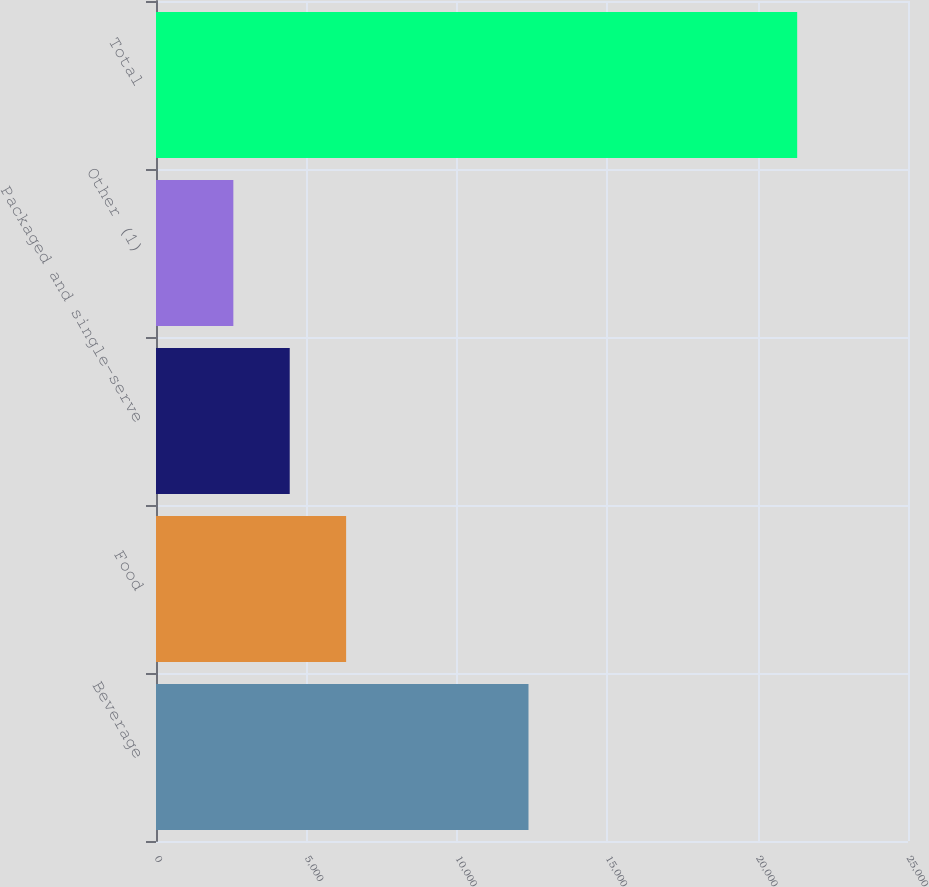Convert chart. <chart><loc_0><loc_0><loc_500><loc_500><bar_chart><fcel>Beverage<fcel>Food<fcel>Packaged and single-serve<fcel>Other (1)<fcel>Total<nl><fcel>12383.4<fcel>6320.38<fcel>4445.94<fcel>2571.5<fcel>21315.9<nl></chart> 